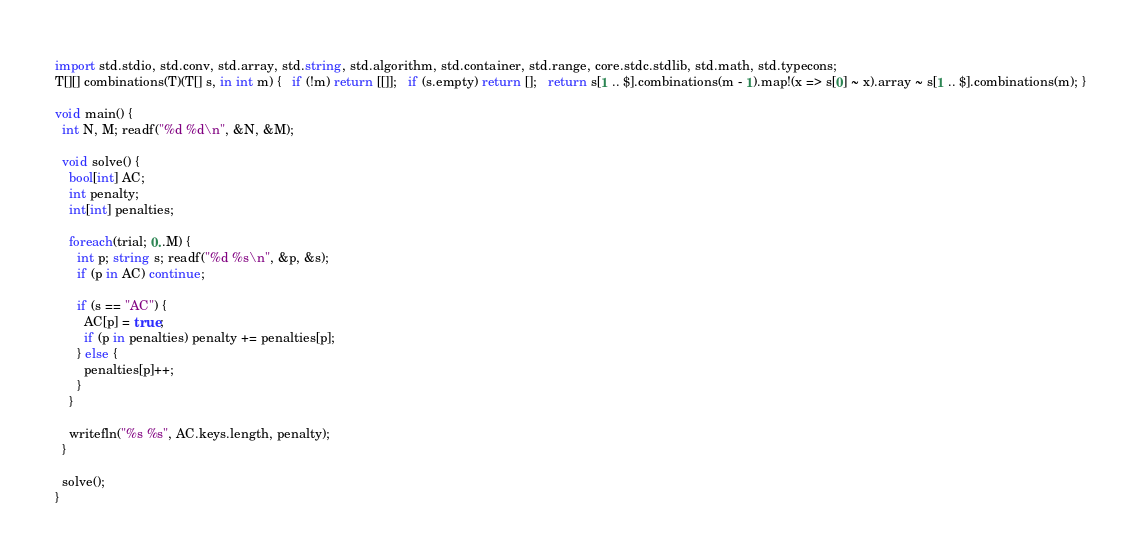<code> <loc_0><loc_0><loc_500><loc_500><_D_>import std.stdio, std.conv, std.array, std.string, std.algorithm, std.container, std.range, core.stdc.stdlib, std.math, std.typecons;
T[][] combinations(T)(T[] s, in int m) {   if (!m) return [[]];   if (s.empty) return [];   return s[1 .. $].combinations(m - 1).map!(x => s[0] ~ x).array ~ s[1 .. $].combinations(m); }

void main() {
  int N, M; readf("%d %d\n", &N, &M);

  void solve() {
    bool[int] AC;
    int penalty;
    int[int] penalties;

    foreach(trial; 0..M) {
      int p; string s; readf("%d %s\n", &p, &s);
      if (p in AC) continue;
      
      if (s == "AC") {
        AC[p] = true;
        if (p in penalties) penalty += penalties[p];
      } else {
        penalties[p]++;
      }
    }

    writefln("%s %s", AC.keys.length, penalty);
  }

  solve();
}
</code> 